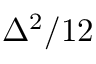<formula> <loc_0><loc_0><loc_500><loc_500>\Delta ^ { 2 } / 1 2</formula> 